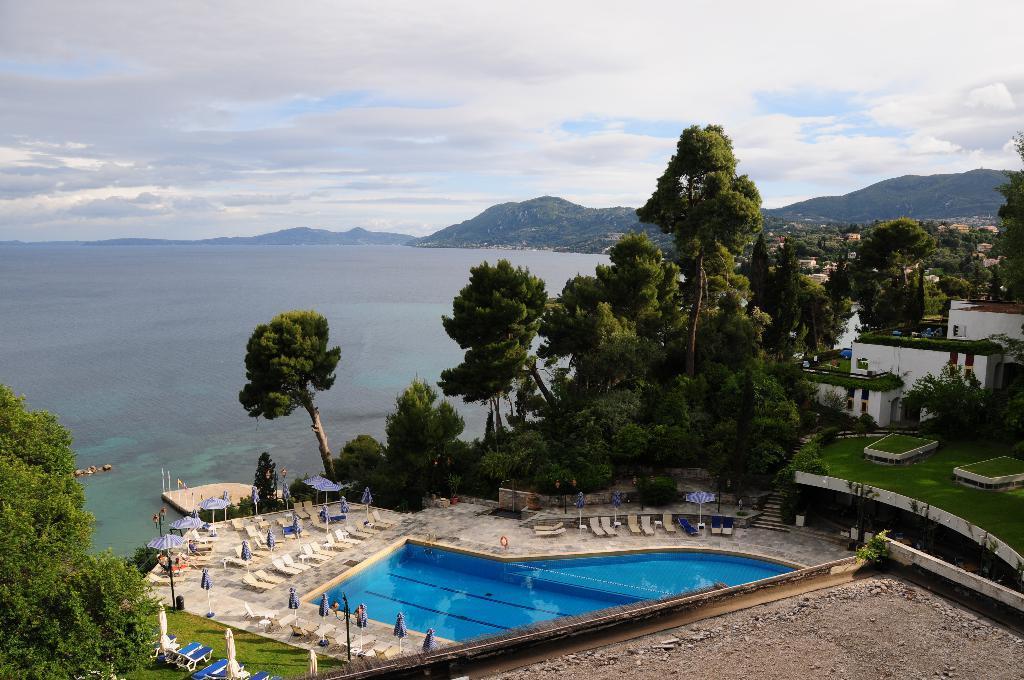Describe this image in one or two sentences. This looks like a swimming pool with the water. These are the pool lounge chairs and the patio umbrellas. I can see the trees with branches and leaves. I think this is the sea with the water flowing. These are the mountains. These look like rooms with windows. I can see the stairs. This is the grass. 